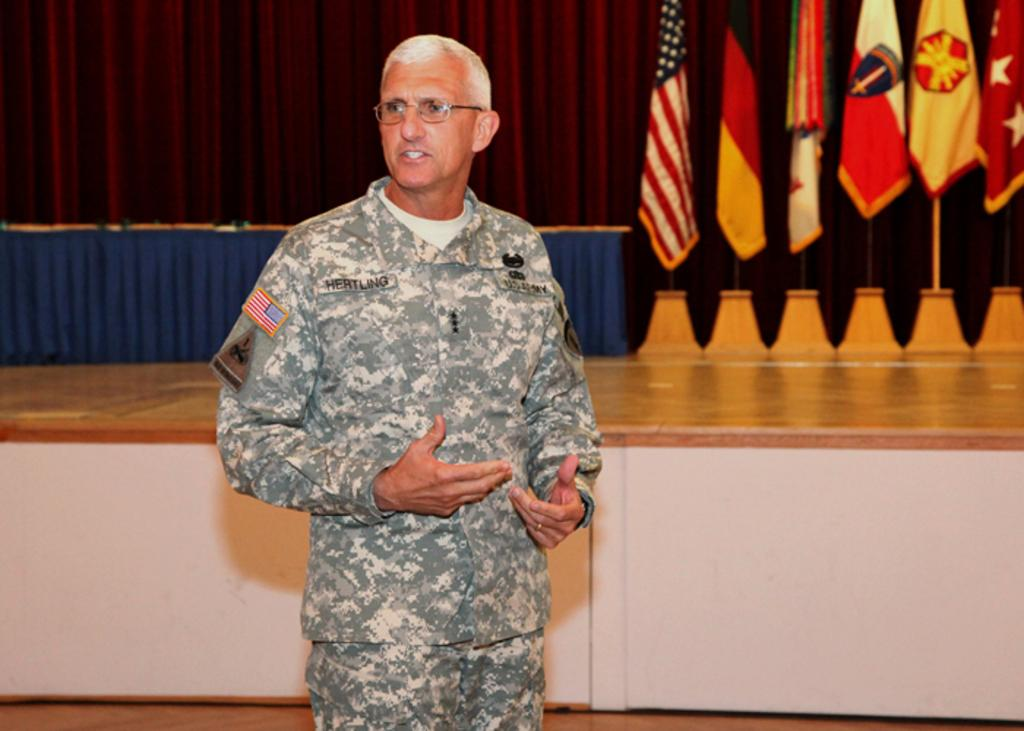What is the man in the image doing? The man is standing and talking in the image. What can be seen in the background of the image? There are flags, a table, curtains, and a stage in the background of the image. What type of creature is sitting on the kettle in the image? There is no kettle or creature present in the image. 